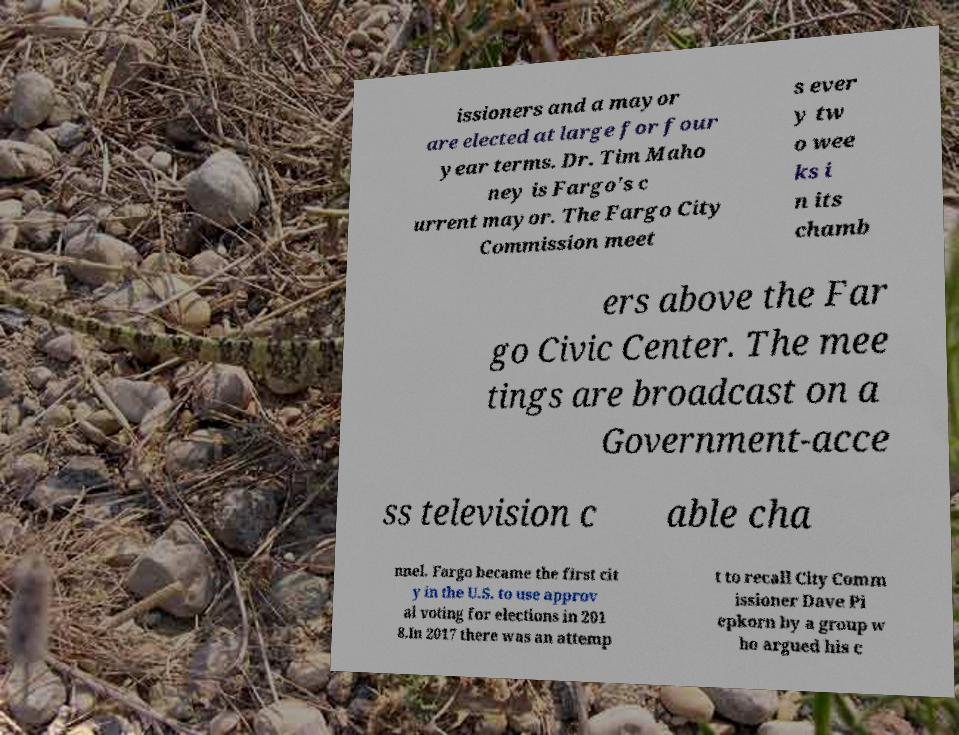Could you extract and type out the text from this image? issioners and a mayor are elected at large for four year terms. Dr. Tim Maho ney is Fargo's c urrent mayor. The Fargo City Commission meet s ever y tw o wee ks i n its chamb ers above the Far go Civic Center. The mee tings are broadcast on a Government-acce ss television c able cha nnel. Fargo became the first cit y in the U.S. to use approv al voting for elections in 201 8.In 2017 there was an attemp t to recall City Comm issioner Dave Pi epkorn by a group w ho argued his c 